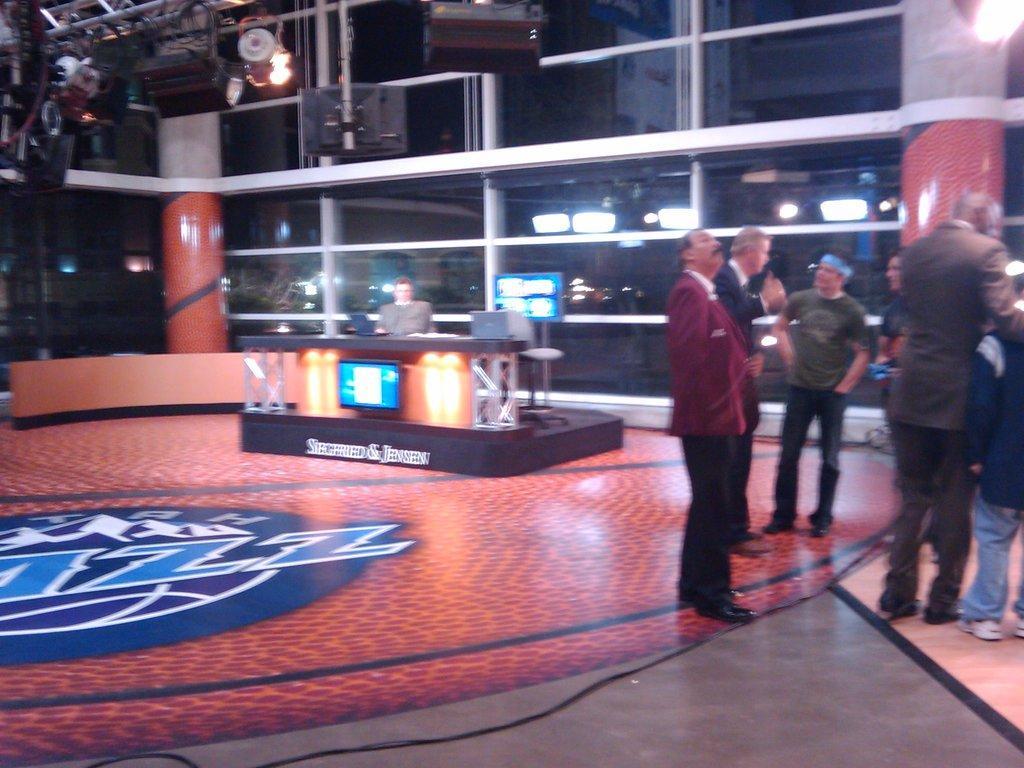Please provide a concise description of this image. In the center of the image we can see a person sitting and there are laptops placed on the table. We can see screens. On the right there are people standing. At the top there is a camera and we can see lights. In the background there are pillars and a wall. 